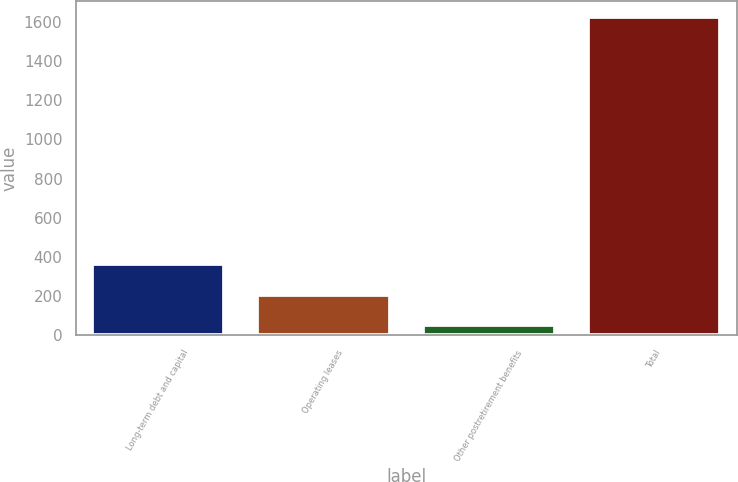Convert chart. <chart><loc_0><loc_0><loc_500><loc_500><bar_chart><fcel>Long-term debt and capital<fcel>Operating leases<fcel>Other postretirement benefits<fcel>Total<nl><fcel>365.4<fcel>208.2<fcel>51<fcel>1623<nl></chart> 